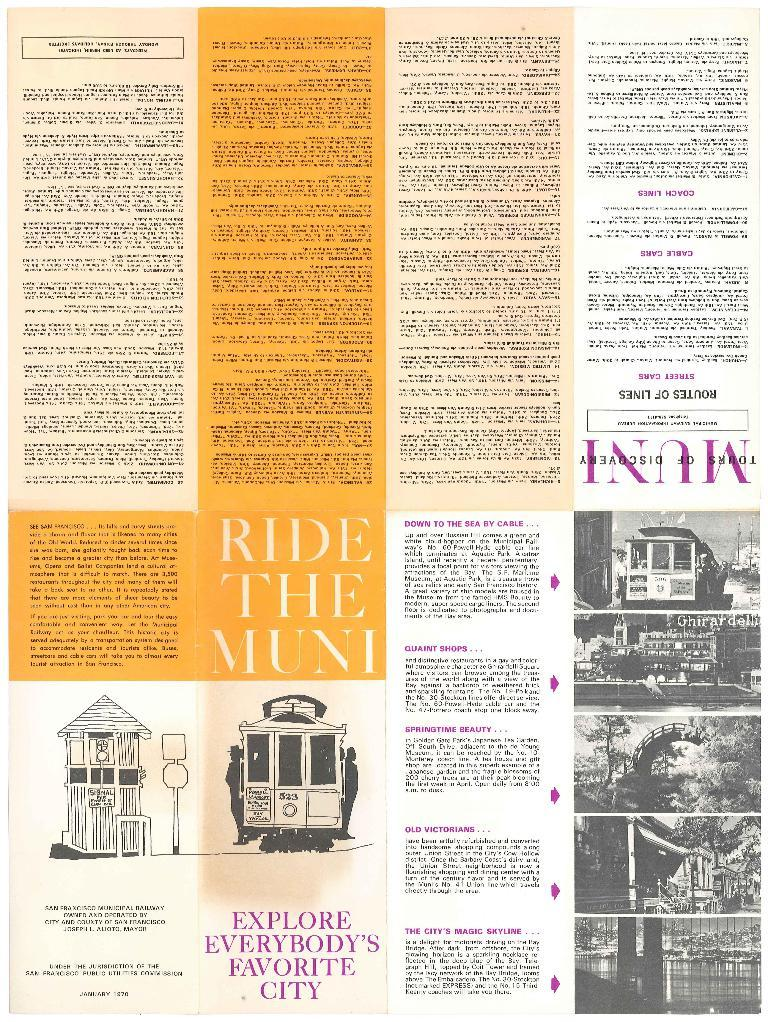What is present in the image that contains information? There is a paper in the image that contains information. What type of content can be found on the paper? The paper contains both text and pictures. How many girls are walking on the hot trail in the image? There are no girls or trails present in the image; it only contains a paper with text and pictures. 